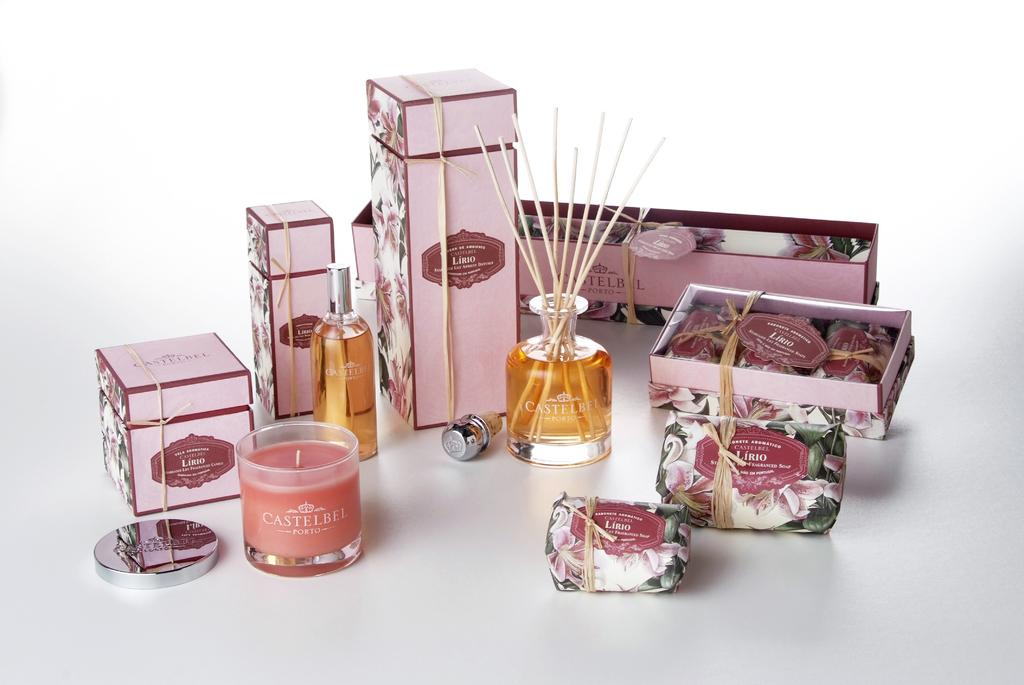Provide a one-sentence caption for the provided image. A product display layout for Castelbel Porto products showing candles,diffusers, and sprays. 